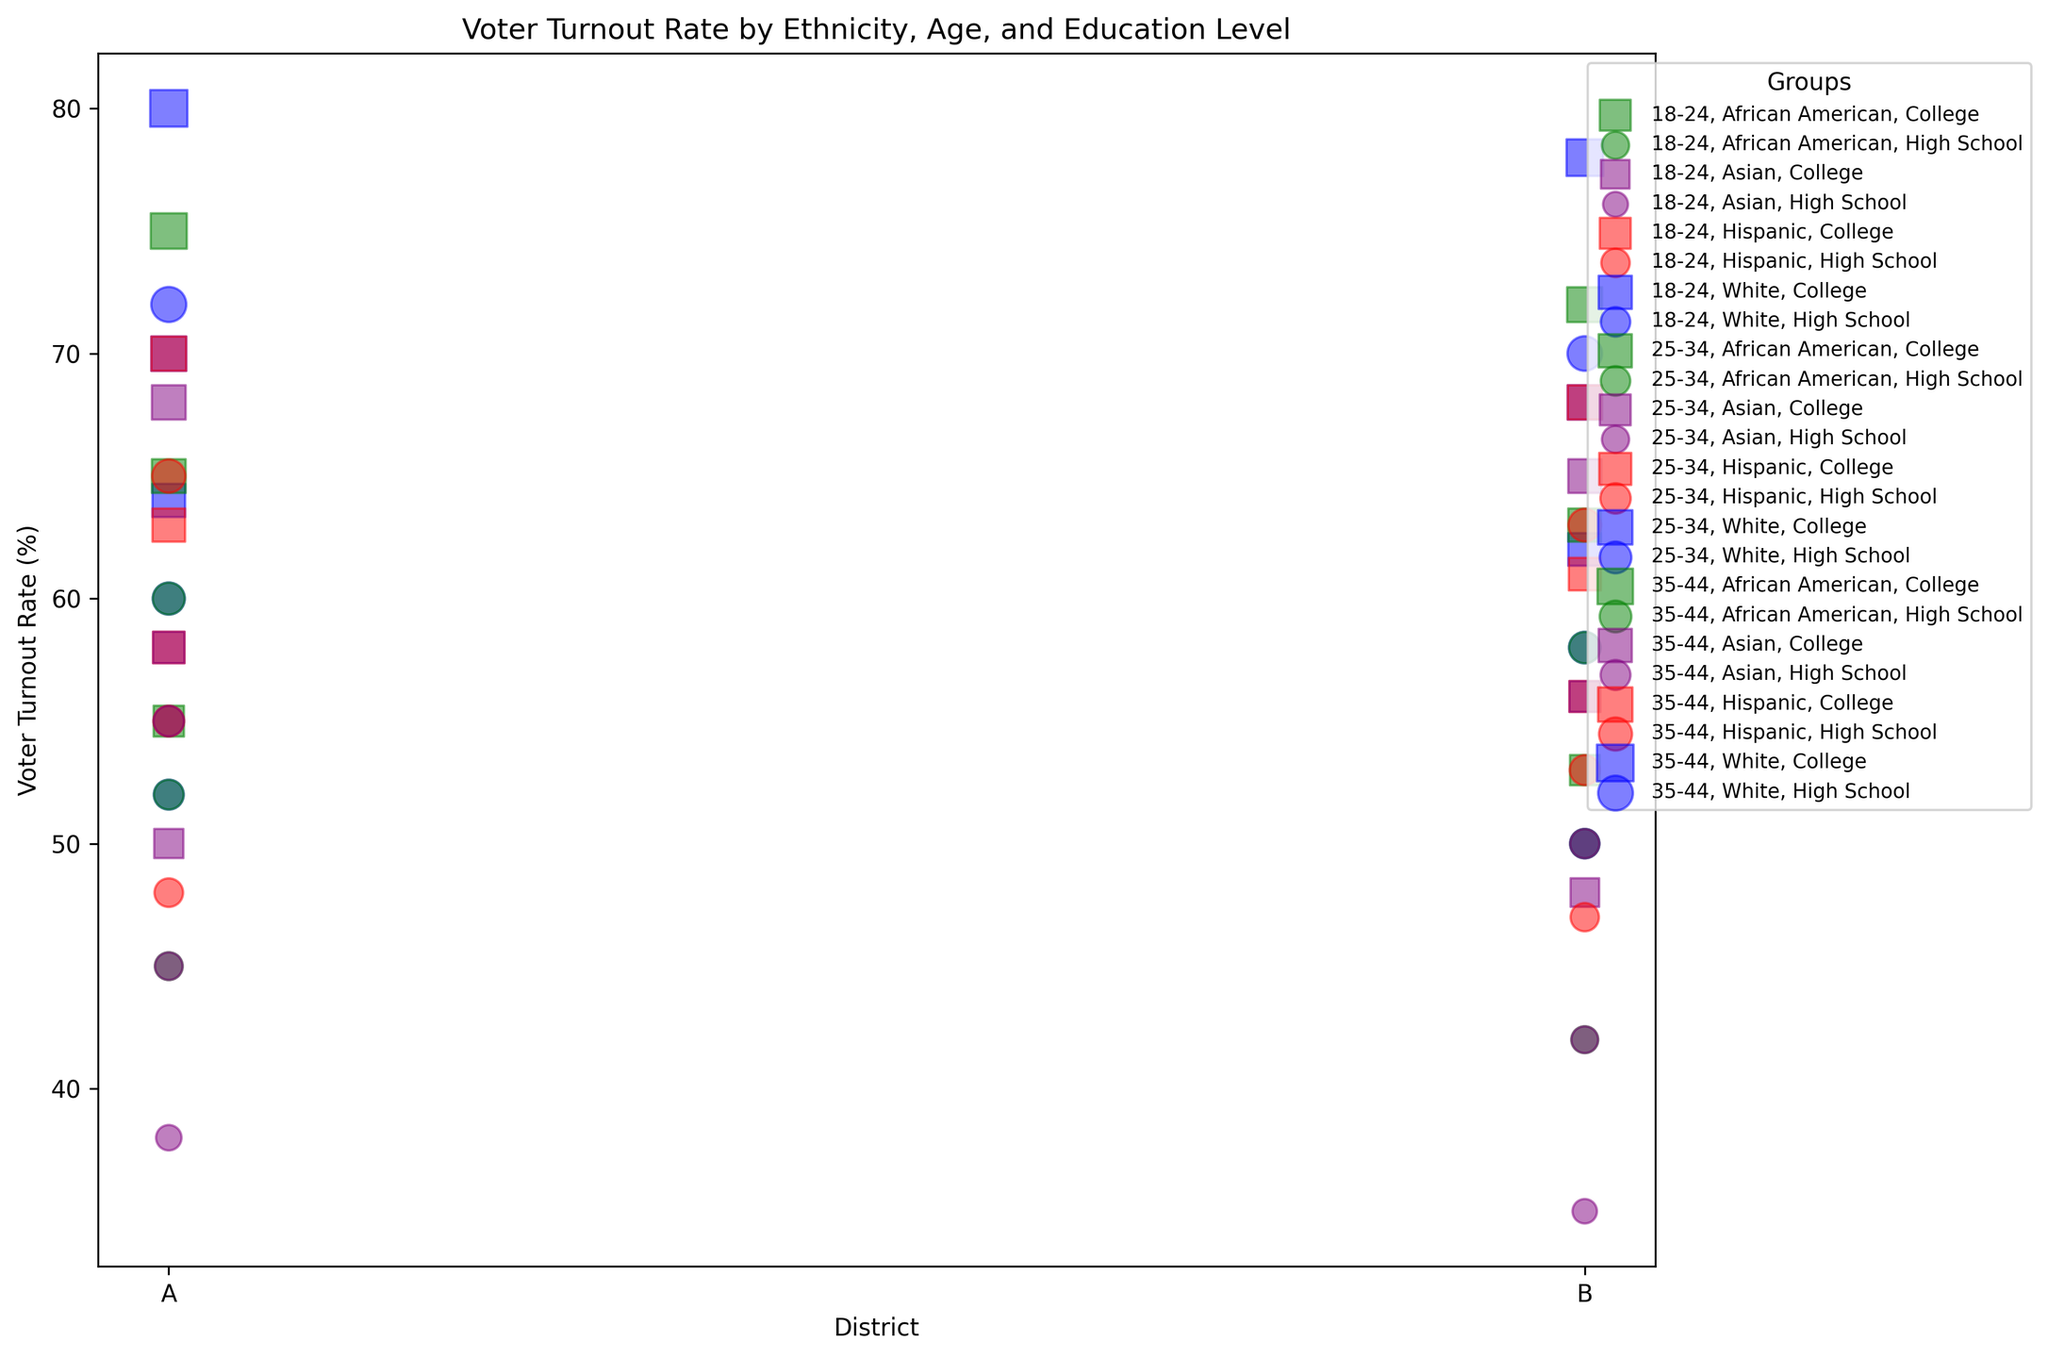What is the voter turnout rate for Hispanic, High School graduates in District A and District B? Look for the bubbles that represent Hispanic, High School graduates in both districts. The y-axis value for District A is 65, and for District B is 63.
Answer: District A: 65, District B: 63 Which ethnic group has the lowest voter turnout rate among 18-24 year olds with a High School education in District B? Identify the bubbles for 18-24 age group, High School education in District B. The y-axis values are 50 for White, 42 for African American, 47 for Hispanic, and 35 for Asian. The lowest value is 35.
Answer: Asian Among 35-44 year olds with a College education, which district has a higher voter turnout rate for African Americans? Compare the bubbles representing 35-44 age group, College education for African Americans in both districts. The y-axis value in District A is 75, while in District B it is 72.
Answer: District A What is the average voter turnout rate for African American High School graduates across both districts? Average the y-axis values for African American, High School graduates in both districts. The values are 45 (District A, 18-24), 52 (District A, 25-34), 60 (District A, 35-44), 42 (District B, 18-24), 50 (District B, 25-34), and 58 (District B, 35-44). The sum is (45 + 52 + 60 + 42 + 50 + 58) = 307. The average is 307 / 6 ≈ 51.17.
Answer: 51.17 How does the voter turnout rate for 25-34 year-old College-educated Asians compare between the two districts? Compare the bubbles for 25-34 age group, College education, Asians in both districts. The y-axis value in District A is 58, and in District B it is 56.
Answer: District A: 58, District B: 56 What is the total voter turnout rate for all White 18-24 year olds with a College education? Sum the y-axis values for White, 18-24, College category in both districts. The values are 64 (District A) and 62 (District B). The sum is (64 + 62) = 126.
Answer: 126 Which demographic has the largest bubble size in the 35-44 age group with College education in District A? Look for the largest bubble size in the 35-44 age group with College education in District A. The bubble sizes are 80 (White), 75 (African American), 70 (Hispanic), and 68 (Asian). The largest value is 80.
Answer: White Compare the voter turnout rates of 25-34 year-old Hispanic High School graduates and College graduates in District B. Identify the bubbles for 25-34 age group, Hispanic, both High School and College in District B. The y-axis values are 53 for High School and 61 for College.
Answer: High School: 53, College: 61 